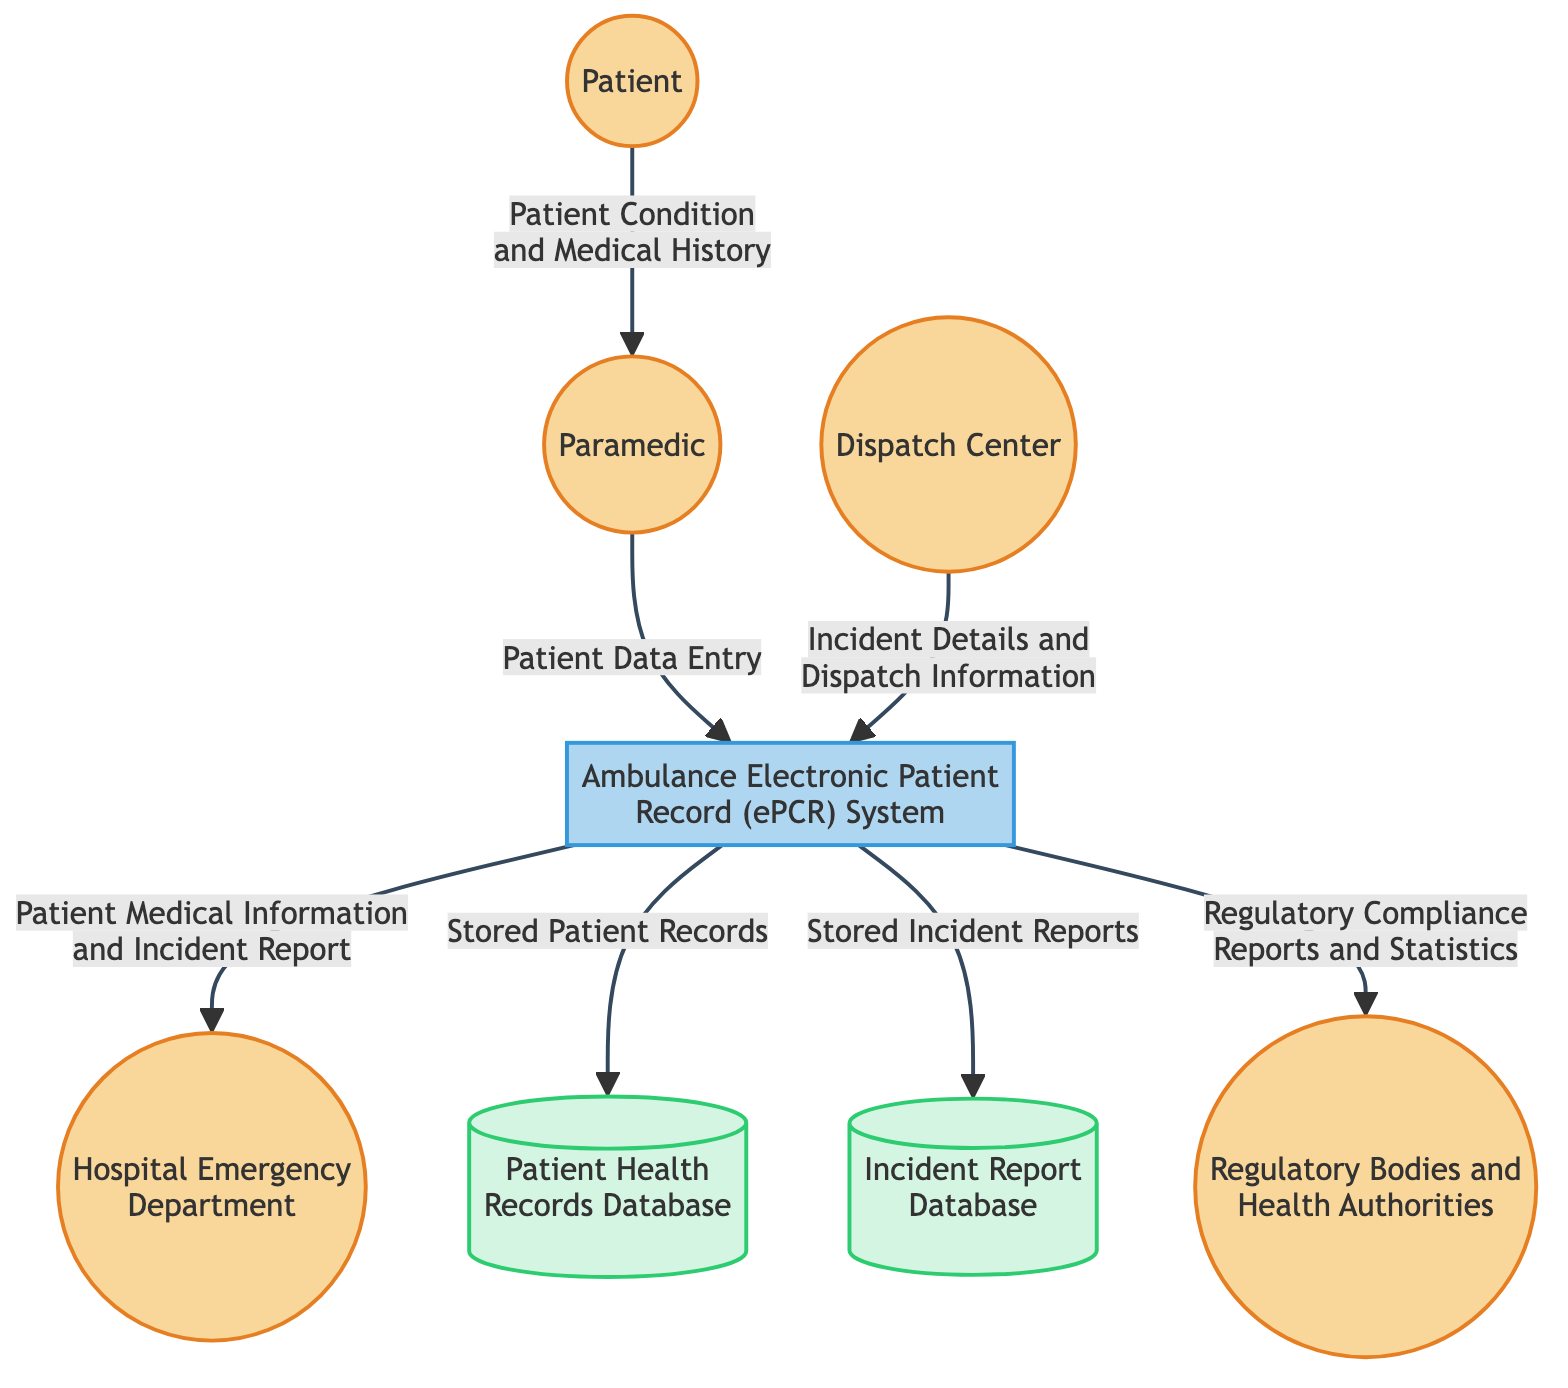What is the external entity that provides patient condition and medical history? The diagram indicates that the patient is the external entity supplying this information directly to the paramedic.
Answer: Patient How many data stores are present in the diagram? By reviewing the diagram, we see two data stores: the Patient Health Records Database and the Incident Report Database. Thus, the count is 2.
Answer: 2 Which external entity receives patient medical information and incident report from the ePCR System? The diagram clearly shows that the Hospital Emergency Department is the recipient of the information from the Ambulance Electronic Patient Record System.
Answer: Hospital Emergency Department What type of information is sent from the Dispatch Center to the ePCR System? The diagram specifies that "Incident Details and Dispatch Information" are sent from the Dispatch Center to the ePCR System.
Answer: Incident Details and Dispatch Information What does the ePCR System store in the Incident Report Database? According to the diagram, the ePCR System stores "Stored Incident Reports" in the Incident Report Database.
Answer: Stored Incident Reports What is the relationship between the Paramedic and the ePCR System? The diagram indicates a direct flow of data where the Paramedic inputs "Patient Data Entry" into the ePCR System, establishing this relationship.
Answer: Patient Data Entry Which regulatory body receives reports and statistics from the ePCR System? Based on the diagram, the Regulatory Bodies and Health Authorities are the entities receiving Regulatory Compliance Reports and Statistics from the ePCR System.
Answer: Regulatory Bodies and Health Authorities What type of data is sent from the ePCR System to the Patient Health Records Database? The diagram details that the data sent from the ePCR System to the Patient Health Records Database is "Stored Patient Records."
Answer: Stored Patient Records How many external entities are represented in the diagram? By counting the external entities listed, we identify five: Patient, Paramedic, Dispatch Center, Hospital Emergency Department, and Regulatory Bodies and Health Authorities, leading to a total of 5.
Answer: 5 